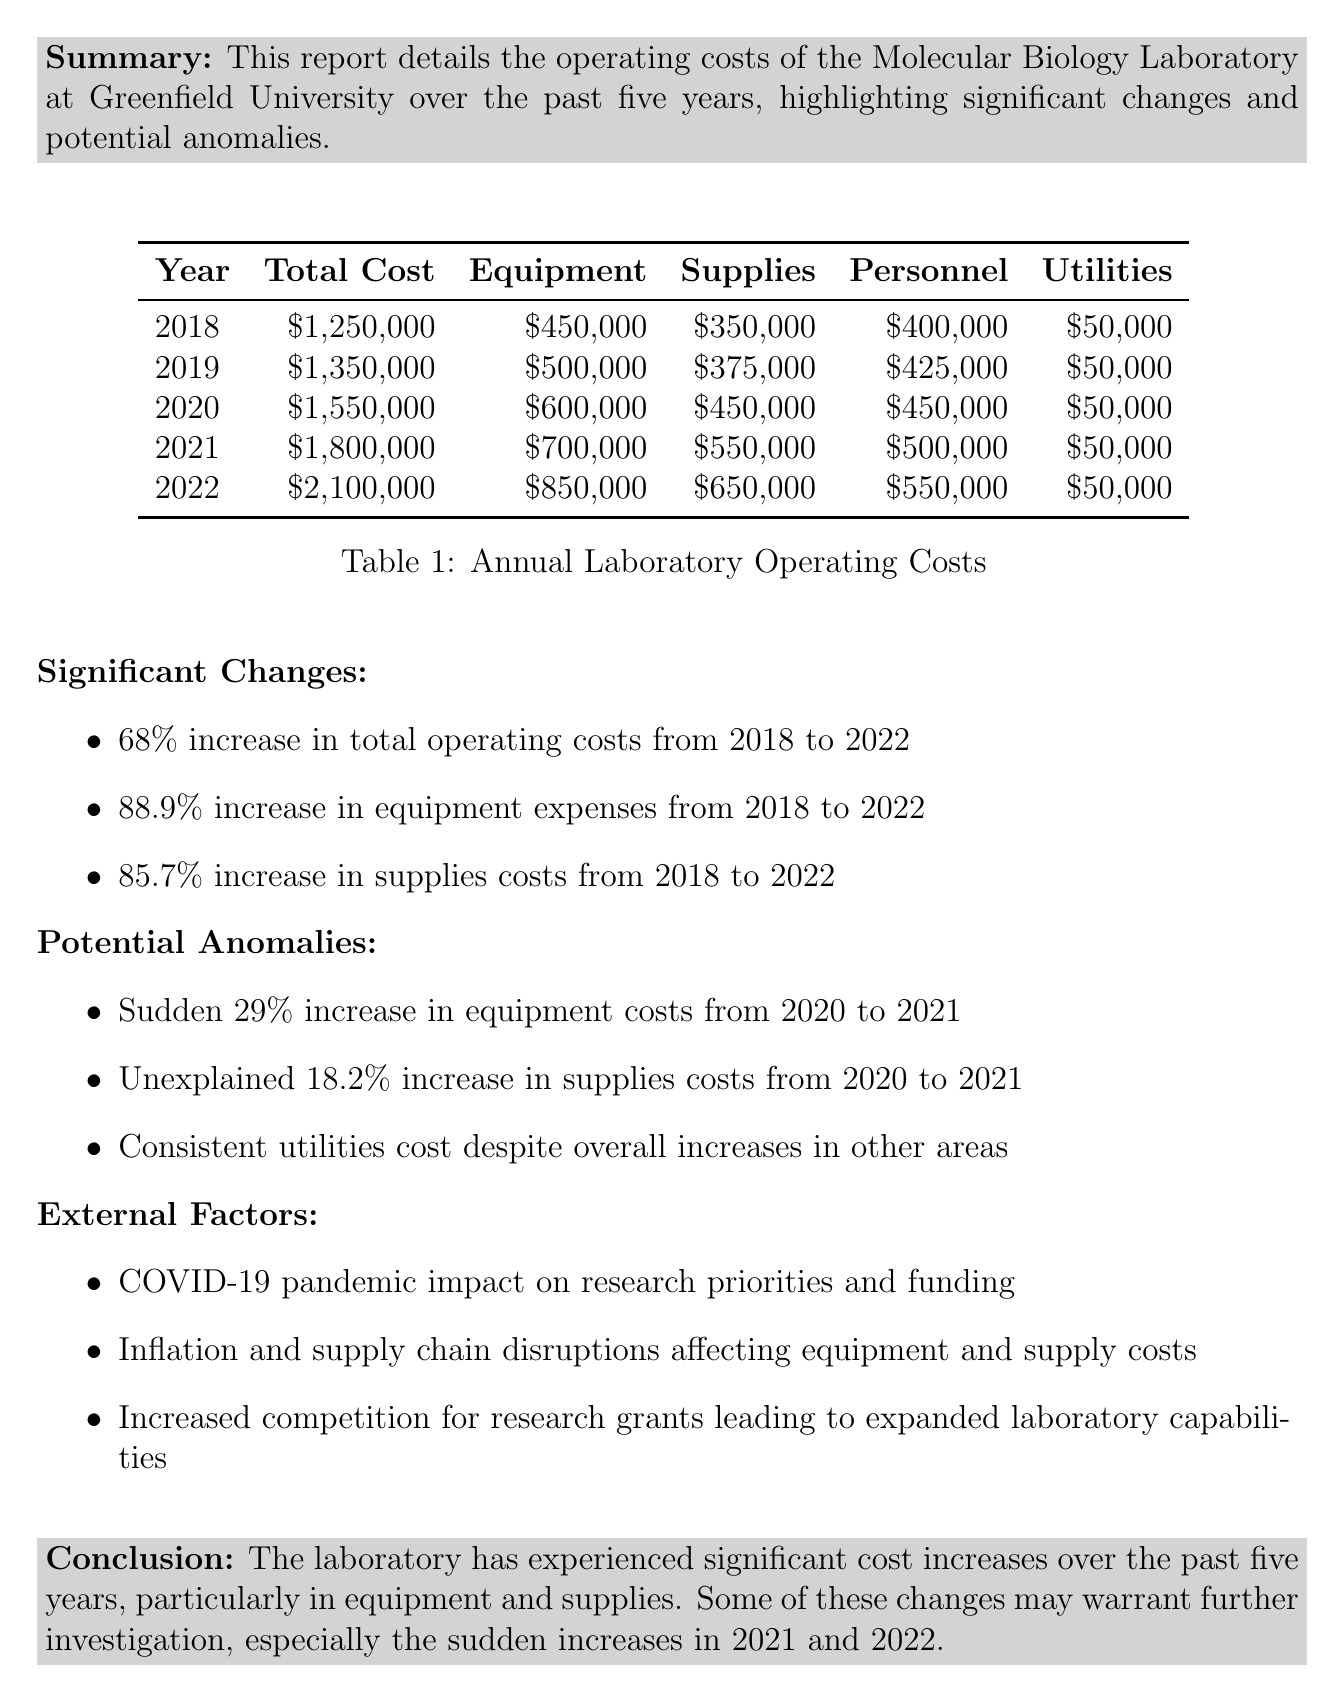what is the total cost for the year 2020? The total cost for 2020 is listed in the annual costs table as $1,550,000.
Answer: $1,550,000 what was the equipment cost in 2021? The equipment cost for 2021 can be found in the annual costs table, showing $700,000.
Answer: $700,000 how much did supplies costs increase from 2018 to 2022? The increase in supplies costs over that period is detailed in the significant changes section as an increase of 85.7%.
Answer: 85.7% which year saw a 29% increase in equipment costs? The sudden 29% increase in equipment costs occurred from 2020 to 2021, as stated in the potential anomalies section.
Answer: 2021 what was the total cost for the laboratory in 2019? The total cost for 2019 is provided in the annual costs table as $1,350,000.
Answer: $1,350,000 what external factor is cited affecting equipment costs? One of the external factors affecting equipment costs is inflation and supply chain disruptions, as mentioned in the external factors section.
Answer: inflation and supply chain disruptions what is the percentage increase in total operating costs from 2018 to 2022? The report highlights a 68% increase in total operating costs during this time period in the significant changes section.
Answer: 68% how consistent was the utilities cost over the years? The utilities cost is noted to be consistent at $50,000 despite increases in other expenses, as referenced in the potential anomalies section.
Answer: consistent what is the main conclusion of the report? The conclusion states that the laboratory experienced significant cost increases, especially in equipment and supplies, and some changes warrant further investigation.
Answer: significant cost increases 